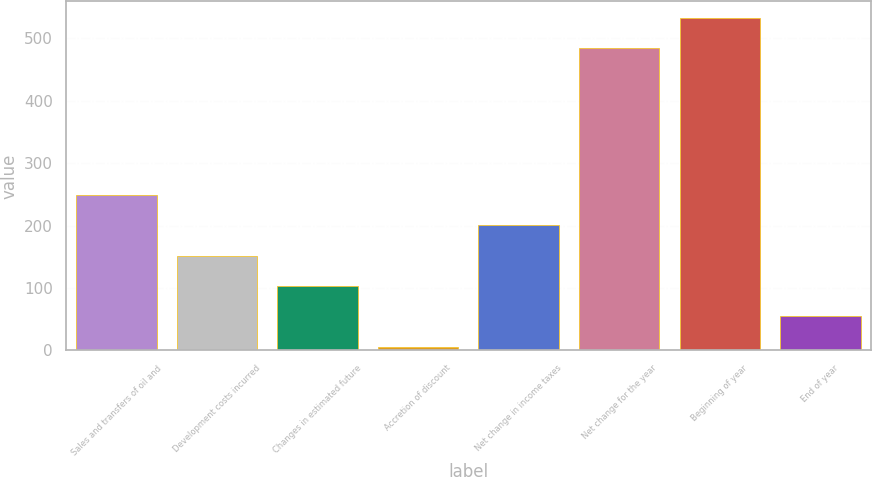Convert chart to OTSL. <chart><loc_0><loc_0><loc_500><loc_500><bar_chart><fcel>Sales and transfers of oil and<fcel>Development costs incurred<fcel>Changes in estimated future<fcel>Accretion of discount<fcel>Net change in income taxes<fcel>Net change for the year<fcel>Beginning of year<fcel>End of year<nl><fcel>249<fcel>151.8<fcel>103.2<fcel>6<fcel>200.4<fcel>484<fcel>532.6<fcel>54.6<nl></chart> 